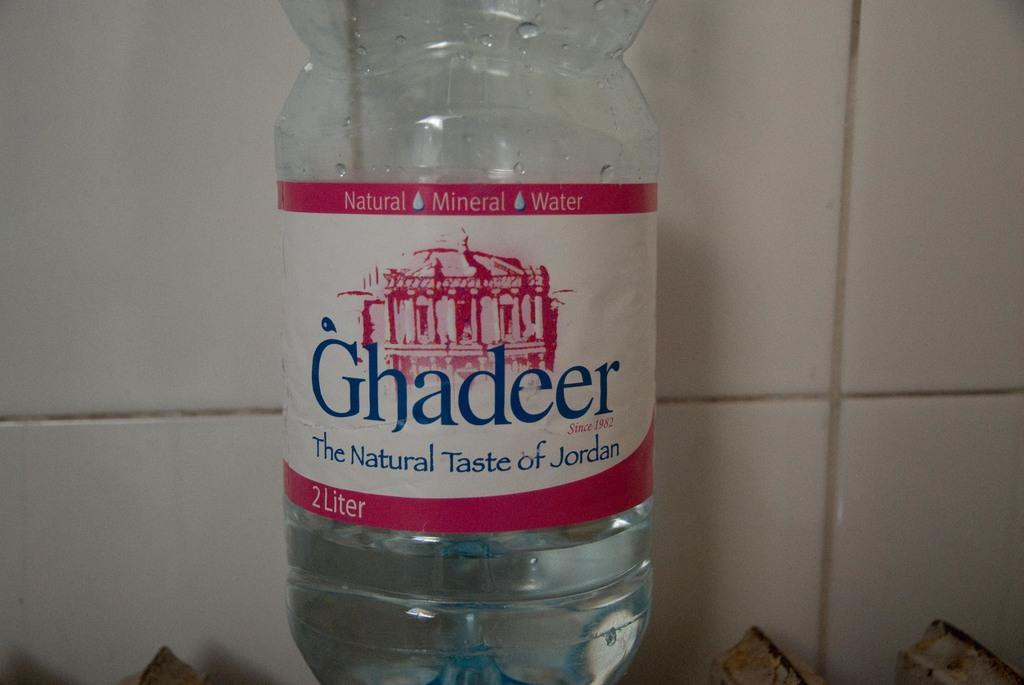<image>
Present a compact description of the photo's key features. A bottle of Ghadeer says it has the natural taste of Jordan. 